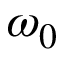<formula> <loc_0><loc_0><loc_500><loc_500>\omega _ { 0 }</formula> 